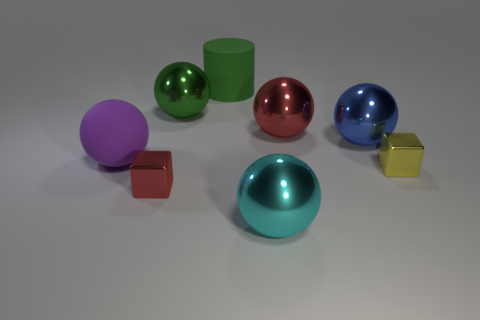Subtract all green shiny spheres. How many spheres are left? 4 Add 1 big gray metallic blocks. How many objects exist? 9 Subtract all blue balls. How many balls are left? 4 Subtract all spheres. How many objects are left? 3 Subtract all big blue shiny objects. Subtract all large metallic spheres. How many objects are left? 3 Add 8 cyan objects. How many cyan objects are left? 9 Add 4 small blue matte balls. How many small blue matte balls exist? 4 Subtract 0 gray cylinders. How many objects are left? 8 Subtract 2 spheres. How many spheres are left? 3 Subtract all gray blocks. Subtract all gray cylinders. How many blocks are left? 2 